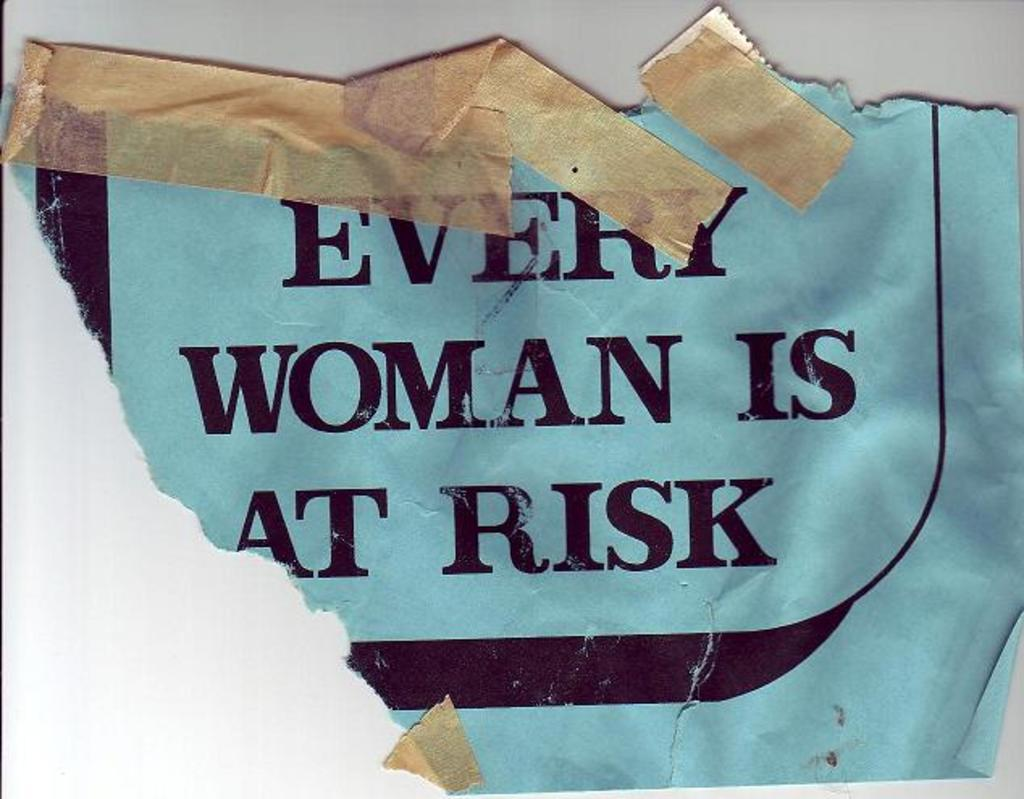<image>
Write a terse but informative summary of the picture. Torn blue flyer with the saying Every Woman Is At Risk. 